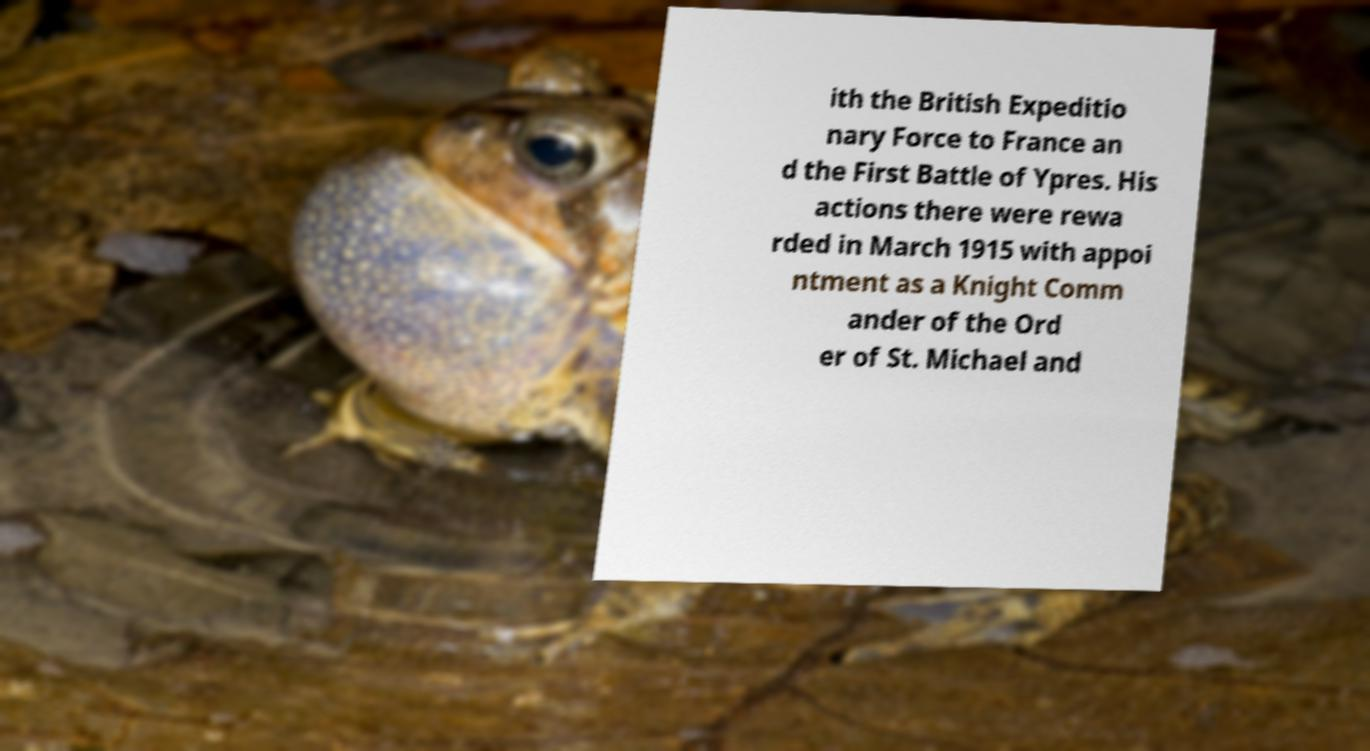What messages or text are displayed in this image? I need them in a readable, typed format. ith the British Expeditio nary Force to France an d the First Battle of Ypres. His actions there were rewa rded in March 1915 with appoi ntment as a Knight Comm ander of the Ord er of St. Michael and 